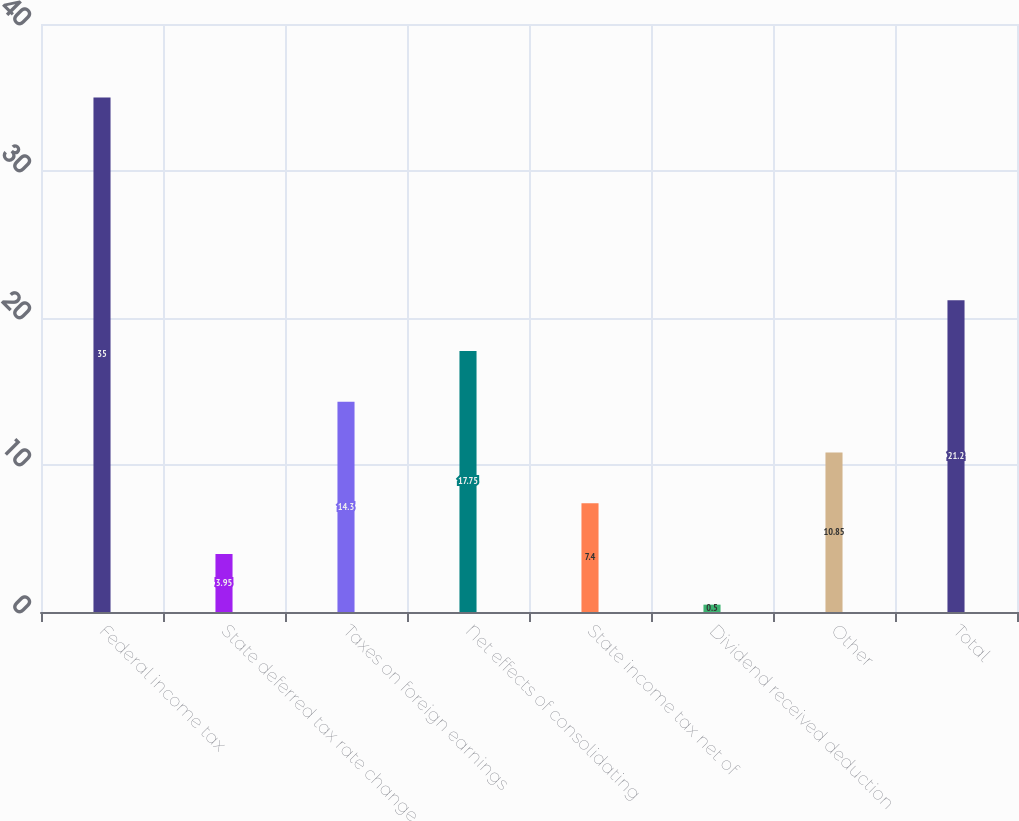<chart> <loc_0><loc_0><loc_500><loc_500><bar_chart><fcel>Federal income tax<fcel>State deferred tax rate change<fcel>Taxes on foreign earnings<fcel>Net effects of consolidating<fcel>State income tax net of<fcel>Dividend received deduction<fcel>Other<fcel>Total<nl><fcel>35<fcel>3.95<fcel>14.3<fcel>17.75<fcel>7.4<fcel>0.5<fcel>10.85<fcel>21.2<nl></chart> 